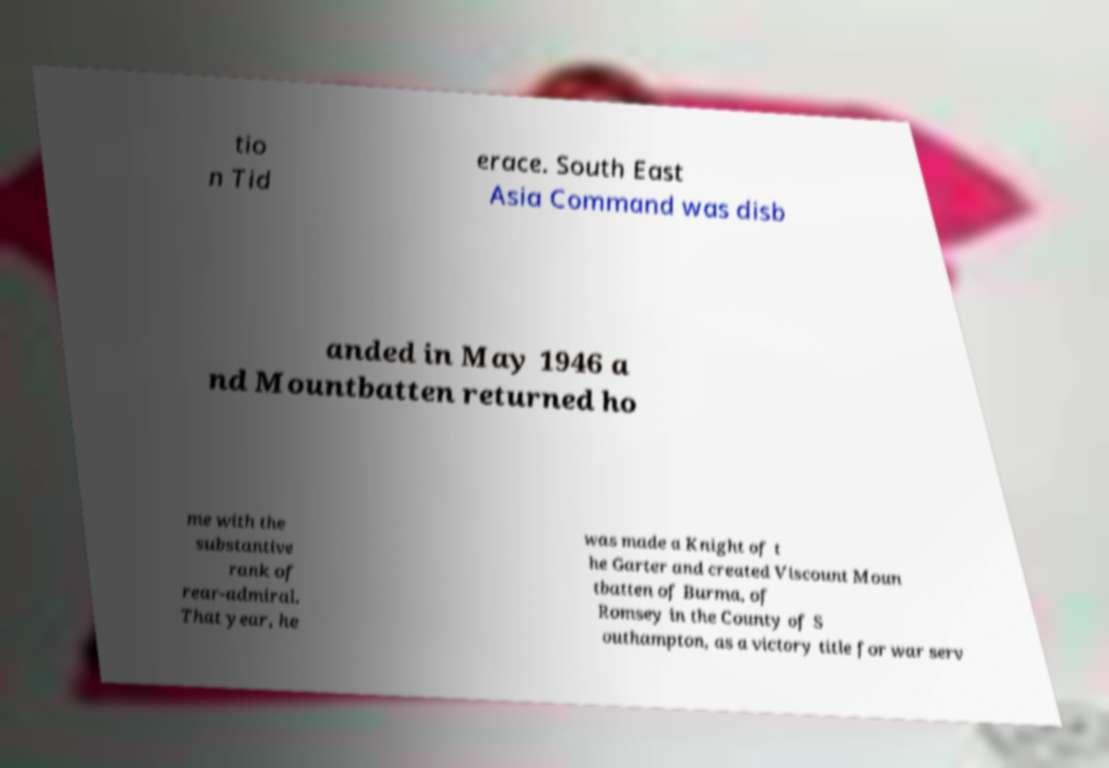Could you assist in decoding the text presented in this image and type it out clearly? tio n Tid erace. South East Asia Command was disb anded in May 1946 a nd Mountbatten returned ho me with the substantive rank of rear-admiral. That year, he was made a Knight of t he Garter and created Viscount Moun tbatten of Burma, of Romsey in the County of S outhampton, as a victory title for war serv 